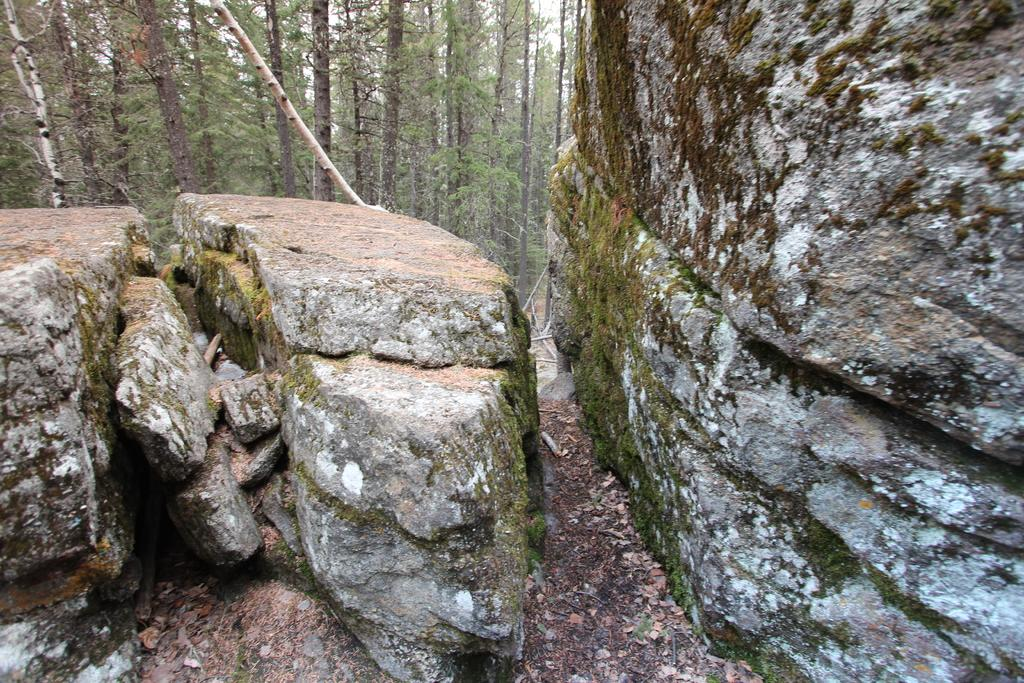What can be seen on the left side of the image? There are rocks on a hill on the left side of the image. What is present on the right side of the image? There are rocks on the ground on the right side of the image. What type of vegetation is visible in the background of the image? There are trees in the background of the image. What is visible in the sky in the background of the image? The sky is visible in the background of the image. How many marks can be seen on the rocks in the image? There are no marks visible on the rocks in the image. What type of loss is depicted in the image? There is no loss depicted in the image; it features rocks and trees. 